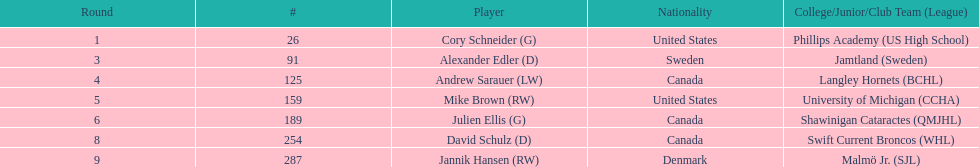Enumerate every athlete selected from canada. Andrew Sarauer (LW), Julien Ellis (G), David Schulz (D). 